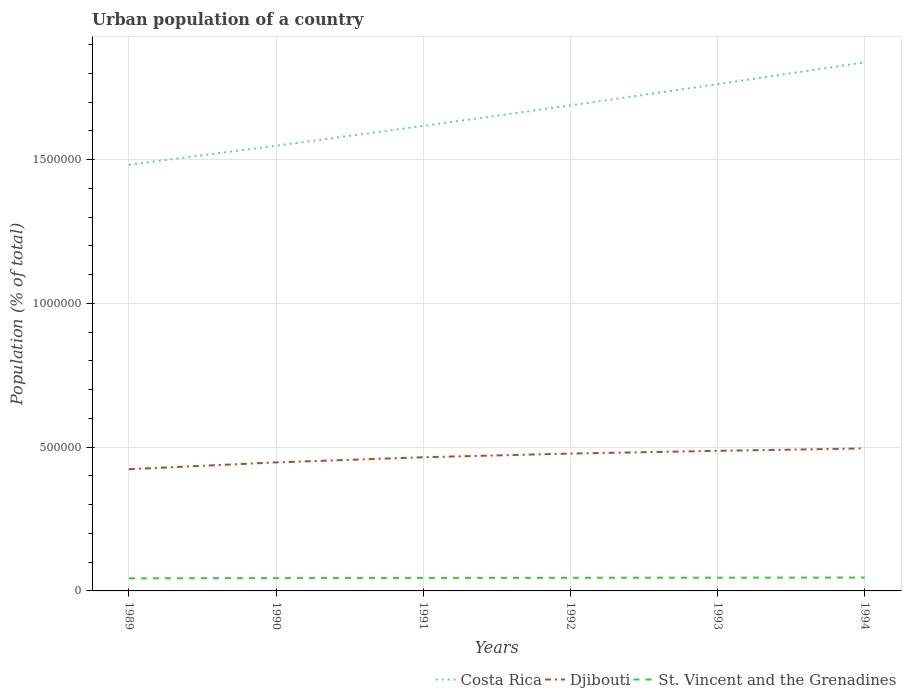How many different coloured lines are there?
Your response must be concise. 3. Does the line corresponding to Costa Rica intersect with the line corresponding to Djibouti?
Keep it short and to the point. No. Is the number of lines equal to the number of legend labels?
Offer a terse response. Yes. Across all years, what is the maximum urban population in Djibouti?
Your answer should be compact. 4.23e+05. What is the total urban population in Djibouti in the graph?
Provide a succinct answer. -8431. What is the difference between the highest and the second highest urban population in Djibouti?
Your response must be concise. 7.22e+04. How many lines are there?
Your answer should be very brief. 3. How many years are there in the graph?
Your answer should be very brief. 6. What is the difference between two consecutive major ticks on the Y-axis?
Offer a very short reply. 5.00e+05. Does the graph contain grids?
Your response must be concise. Yes. How many legend labels are there?
Your response must be concise. 3. What is the title of the graph?
Provide a short and direct response. Urban population of a country. What is the label or title of the Y-axis?
Your answer should be compact. Population (% of total). What is the Population (% of total) in Costa Rica in 1989?
Your answer should be very brief. 1.48e+06. What is the Population (% of total) of Djibouti in 1989?
Provide a succinct answer. 4.23e+05. What is the Population (% of total) of St. Vincent and the Grenadines in 1989?
Offer a terse response. 4.37e+04. What is the Population (% of total) in Costa Rica in 1990?
Make the answer very short. 1.55e+06. What is the Population (% of total) in Djibouti in 1990?
Your answer should be very brief. 4.47e+05. What is the Population (% of total) in St. Vincent and the Grenadines in 1990?
Provide a short and direct response. 4.45e+04. What is the Population (% of total) of Costa Rica in 1991?
Offer a very short reply. 1.62e+06. What is the Population (% of total) of Djibouti in 1991?
Offer a terse response. 4.65e+05. What is the Population (% of total) in St. Vincent and the Grenadines in 1991?
Ensure brevity in your answer.  4.52e+04. What is the Population (% of total) of Costa Rica in 1992?
Provide a short and direct response. 1.69e+06. What is the Population (% of total) in Djibouti in 1992?
Your answer should be compact. 4.78e+05. What is the Population (% of total) in St. Vincent and the Grenadines in 1992?
Offer a terse response. 4.57e+04. What is the Population (% of total) of Costa Rica in 1993?
Keep it short and to the point. 1.76e+06. What is the Population (% of total) in Djibouti in 1993?
Ensure brevity in your answer.  4.87e+05. What is the Population (% of total) of St. Vincent and the Grenadines in 1993?
Ensure brevity in your answer.  4.61e+04. What is the Population (% of total) of Costa Rica in 1994?
Keep it short and to the point. 1.84e+06. What is the Population (% of total) in Djibouti in 1994?
Your answer should be compact. 4.96e+05. What is the Population (% of total) of St. Vincent and the Grenadines in 1994?
Offer a terse response. 4.65e+04. Across all years, what is the maximum Population (% of total) of Costa Rica?
Provide a succinct answer. 1.84e+06. Across all years, what is the maximum Population (% of total) in Djibouti?
Your answer should be compact. 4.96e+05. Across all years, what is the maximum Population (% of total) of St. Vincent and the Grenadines?
Make the answer very short. 4.65e+04. Across all years, what is the minimum Population (% of total) of Costa Rica?
Your response must be concise. 1.48e+06. Across all years, what is the minimum Population (% of total) of Djibouti?
Offer a very short reply. 4.23e+05. Across all years, what is the minimum Population (% of total) in St. Vincent and the Grenadines?
Provide a succinct answer. 4.37e+04. What is the total Population (% of total) in Costa Rica in the graph?
Ensure brevity in your answer.  9.94e+06. What is the total Population (% of total) of Djibouti in the graph?
Provide a succinct answer. 2.80e+06. What is the total Population (% of total) of St. Vincent and the Grenadines in the graph?
Ensure brevity in your answer.  2.72e+05. What is the difference between the Population (% of total) in Costa Rica in 1989 and that in 1990?
Offer a terse response. -6.61e+04. What is the difference between the Population (% of total) in Djibouti in 1989 and that in 1990?
Your response must be concise. -2.36e+04. What is the difference between the Population (% of total) in St. Vincent and the Grenadines in 1989 and that in 1990?
Your response must be concise. -783. What is the difference between the Population (% of total) in Costa Rica in 1989 and that in 1991?
Offer a very short reply. -1.35e+05. What is the difference between the Population (% of total) in Djibouti in 1989 and that in 1991?
Provide a succinct answer. -4.15e+04. What is the difference between the Population (% of total) in St. Vincent and the Grenadines in 1989 and that in 1991?
Make the answer very short. -1491. What is the difference between the Population (% of total) of Costa Rica in 1989 and that in 1992?
Provide a succinct answer. -2.06e+05. What is the difference between the Population (% of total) of Djibouti in 1989 and that in 1992?
Ensure brevity in your answer.  -5.43e+04. What is the difference between the Population (% of total) of St. Vincent and the Grenadines in 1989 and that in 1992?
Keep it short and to the point. -1956. What is the difference between the Population (% of total) in Costa Rica in 1989 and that in 1993?
Provide a short and direct response. -2.80e+05. What is the difference between the Population (% of total) in Djibouti in 1989 and that in 1993?
Provide a short and direct response. -6.38e+04. What is the difference between the Population (% of total) in St. Vincent and the Grenadines in 1989 and that in 1993?
Your response must be concise. -2382. What is the difference between the Population (% of total) of Costa Rica in 1989 and that in 1994?
Keep it short and to the point. -3.56e+05. What is the difference between the Population (% of total) of Djibouti in 1989 and that in 1994?
Give a very brief answer. -7.22e+04. What is the difference between the Population (% of total) in St. Vincent and the Grenadines in 1989 and that in 1994?
Give a very brief answer. -2783. What is the difference between the Population (% of total) in Costa Rica in 1990 and that in 1991?
Provide a succinct answer. -6.89e+04. What is the difference between the Population (% of total) of Djibouti in 1990 and that in 1991?
Provide a short and direct response. -1.79e+04. What is the difference between the Population (% of total) in St. Vincent and the Grenadines in 1990 and that in 1991?
Your answer should be very brief. -708. What is the difference between the Population (% of total) of Costa Rica in 1990 and that in 1992?
Offer a very short reply. -1.40e+05. What is the difference between the Population (% of total) of Djibouti in 1990 and that in 1992?
Make the answer very short. -3.07e+04. What is the difference between the Population (% of total) of St. Vincent and the Grenadines in 1990 and that in 1992?
Keep it short and to the point. -1173. What is the difference between the Population (% of total) of Costa Rica in 1990 and that in 1993?
Your answer should be very brief. -2.14e+05. What is the difference between the Population (% of total) in Djibouti in 1990 and that in 1993?
Your response must be concise. -4.02e+04. What is the difference between the Population (% of total) in St. Vincent and the Grenadines in 1990 and that in 1993?
Your response must be concise. -1599. What is the difference between the Population (% of total) of Costa Rica in 1990 and that in 1994?
Give a very brief answer. -2.90e+05. What is the difference between the Population (% of total) of Djibouti in 1990 and that in 1994?
Make the answer very short. -4.87e+04. What is the difference between the Population (% of total) of St. Vincent and the Grenadines in 1990 and that in 1994?
Offer a very short reply. -2000. What is the difference between the Population (% of total) in Costa Rica in 1991 and that in 1992?
Your answer should be compact. -7.14e+04. What is the difference between the Population (% of total) of Djibouti in 1991 and that in 1992?
Give a very brief answer. -1.28e+04. What is the difference between the Population (% of total) of St. Vincent and the Grenadines in 1991 and that in 1992?
Make the answer very short. -465. What is the difference between the Population (% of total) of Costa Rica in 1991 and that in 1993?
Your response must be concise. -1.45e+05. What is the difference between the Population (% of total) in Djibouti in 1991 and that in 1993?
Your answer should be very brief. -2.23e+04. What is the difference between the Population (% of total) in St. Vincent and the Grenadines in 1991 and that in 1993?
Keep it short and to the point. -891. What is the difference between the Population (% of total) in Costa Rica in 1991 and that in 1994?
Make the answer very short. -2.21e+05. What is the difference between the Population (% of total) of Djibouti in 1991 and that in 1994?
Offer a terse response. -3.07e+04. What is the difference between the Population (% of total) of St. Vincent and the Grenadines in 1991 and that in 1994?
Provide a short and direct response. -1292. What is the difference between the Population (% of total) in Costa Rica in 1992 and that in 1993?
Keep it short and to the point. -7.37e+04. What is the difference between the Population (% of total) of Djibouti in 1992 and that in 1993?
Ensure brevity in your answer.  -9550. What is the difference between the Population (% of total) of St. Vincent and the Grenadines in 1992 and that in 1993?
Offer a terse response. -426. What is the difference between the Population (% of total) in Costa Rica in 1992 and that in 1994?
Keep it short and to the point. -1.50e+05. What is the difference between the Population (% of total) in Djibouti in 1992 and that in 1994?
Make the answer very short. -1.80e+04. What is the difference between the Population (% of total) in St. Vincent and the Grenadines in 1992 and that in 1994?
Offer a very short reply. -827. What is the difference between the Population (% of total) in Costa Rica in 1993 and that in 1994?
Provide a succinct answer. -7.58e+04. What is the difference between the Population (% of total) of Djibouti in 1993 and that in 1994?
Offer a very short reply. -8431. What is the difference between the Population (% of total) of St. Vincent and the Grenadines in 1993 and that in 1994?
Your response must be concise. -401. What is the difference between the Population (% of total) of Costa Rica in 1989 and the Population (% of total) of Djibouti in 1990?
Provide a succinct answer. 1.04e+06. What is the difference between the Population (% of total) in Costa Rica in 1989 and the Population (% of total) in St. Vincent and the Grenadines in 1990?
Offer a very short reply. 1.44e+06. What is the difference between the Population (% of total) in Djibouti in 1989 and the Population (% of total) in St. Vincent and the Grenadines in 1990?
Make the answer very short. 3.79e+05. What is the difference between the Population (% of total) in Costa Rica in 1989 and the Population (% of total) in Djibouti in 1991?
Provide a short and direct response. 1.02e+06. What is the difference between the Population (% of total) in Costa Rica in 1989 and the Population (% of total) in St. Vincent and the Grenadines in 1991?
Offer a very short reply. 1.44e+06. What is the difference between the Population (% of total) of Djibouti in 1989 and the Population (% of total) of St. Vincent and the Grenadines in 1991?
Provide a short and direct response. 3.78e+05. What is the difference between the Population (% of total) in Costa Rica in 1989 and the Population (% of total) in Djibouti in 1992?
Offer a very short reply. 1.00e+06. What is the difference between the Population (% of total) in Costa Rica in 1989 and the Population (% of total) in St. Vincent and the Grenadines in 1992?
Make the answer very short. 1.44e+06. What is the difference between the Population (% of total) of Djibouti in 1989 and the Population (% of total) of St. Vincent and the Grenadines in 1992?
Your answer should be very brief. 3.78e+05. What is the difference between the Population (% of total) in Costa Rica in 1989 and the Population (% of total) in Djibouti in 1993?
Ensure brevity in your answer.  9.95e+05. What is the difference between the Population (% of total) in Costa Rica in 1989 and the Population (% of total) in St. Vincent and the Grenadines in 1993?
Make the answer very short. 1.44e+06. What is the difference between the Population (% of total) of Djibouti in 1989 and the Population (% of total) of St. Vincent and the Grenadines in 1993?
Your answer should be very brief. 3.77e+05. What is the difference between the Population (% of total) in Costa Rica in 1989 and the Population (% of total) in Djibouti in 1994?
Provide a short and direct response. 9.86e+05. What is the difference between the Population (% of total) of Costa Rica in 1989 and the Population (% of total) of St. Vincent and the Grenadines in 1994?
Keep it short and to the point. 1.44e+06. What is the difference between the Population (% of total) of Djibouti in 1989 and the Population (% of total) of St. Vincent and the Grenadines in 1994?
Provide a short and direct response. 3.77e+05. What is the difference between the Population (% of total) of Costa Rica in 1990 and the Population (% of total) of Djibouti in 1991?
Your answer should be compact. 1.08e+06. What is the difference between the Population (% of total) of Costa Rica in 1990 and the Population (% of total) of St. Vincent and the Grenadines in 1991?
Keep it short and to the point. 1.50e+06. What is the difference between the Population (% of total) of Djibouti in 1990 and the Population (% of total) of St. Vincent and the Grenadines in 1991?
Your answer should be compact. 4.02e+05. What is the difference between the Population (% of total) in Costa Rica in 1990 and the Population (% of total) in Djibouti in 1992?
Offer a very short reply. 1.07e+06. What is the difference between the Population (% of total) in Costa Rica in 1990 and the Population (% of total) in St. Vincent and the Grenadines in 1992?
Keep it short and to the point. 1.50e+06. What is the difference between the Population (% of total) of Djibouti in 1990 and the Population (% of total) of St. Vincent and the Grenadines in 1992?
Ensure brevity in your answer.  4.01e+05. What is the difference between the Population (% of total) in Costa Rica in 1990 and the Population (% of total) in Djibouti in 1993?
Provide a succinct answer. 1.06e+06. What is the difference between the Population (% of total) of Costa Rica in 1990 and the Population (% of total) of St. Vincent and the Grenadines in 1993?
Provide a succinct answer. 1.50e+06. What is the difference between the Population (% of total) in Djibouti in 1990 and the Population (% of total) in St. Vincent and the Grenadines in 1993?
Your response must be concise. 4.01e+05. What is the difference between the Population (% of total) of Costa Rica in 1990 and the Population (% of total) of Djibouti in 1994?
Your answer should be very brief. 1.05e+06. What is the difference between the Population (% of total) in Costa Rica in 1990 and the Population (% of total) in St. Vincent and the Grenadines in 1994?
Ensure brevity in your answer.  1.50e+06. What is the difference between the Population (% of total) in Djibouti in 1990 and the Population (% of total) in St. Vincent and the Grenadines in 1994?
Keep it short and to the point. 4.00e+05. What is the difference between the Population (% of total) of Costa Rica in 1991 and the Population (% of total) of Djibouti in 1992?
Provide a succinct answer. 1.14e+06. What is the difference between the Population (% of total) in Costa Rica in 1991 and the Population (% of total) in St. Vincent and the Grenadines in 1992?
Your answer should be very brief. 1.57e+06. What is the difference between the Population (% of total) in Djibouti in 1991 and the Population (% of total) in St. Vincent and the Grenadines in 1992?
Your answer should be very brief. 4.19e+05. What is the difference between the Population (% of total) in Costa Rica in 1991 and the Population (% of total) in Djibouti in 1993?
Your response must be concise. 1.13e+06. What is the difference between the Population (% of total) in Costa Rica in 1991 and the Population (% of total) in St. Vincent and the Grenadines in 1993?
Your answer should be compact. 1.57e+06. What is the difference between the Population (% of total) of Djibouti in 1991 and the Population (% of total) of St. Vincent and the Grenadines in 1993?
Make the answer very short. 4.19e+05. What is the difference between the Population (% of total) in Costa Rica in 1991 and the Population (% of total) in Djibouti in 1994?
Provide a succinct answer. 1.12e+06. What is the difference between the Population (% of total) of Costa Rica in 1991 and the Population (% of total) of St. Vincent and the Grenadines in 1994?
Give a very brief answer. 1.57e+06. What is the difference between the Population (% of total) in Djibouti in 1991 and the Population (% of total) in St. Vincent and the Grenadines in 1994?
Ensure brevity in your answer.  4.18e+05. What is the difference between the Population (% of total) in Costa Rica in 1992 and the Population (% of total) in Djibouti in 1993?
Provide a succinct answer. 1.20e+06. What is the difference between the Population (% of total) of Costa Rica in 1992 and the Population (% of total) of St. Vincent and the Grenadines in 1993?
Ensure brevity in your answer.  1.64e+06. What is the difference between the Population (% of total) in Djibouti in 1992 and the Population (% of total) in St. Vincent and the Grenadines in 1993?
Offer a very short reply. 4.31e+05. What is the difference between the Population (% of total) in Costa Rica in 1992 and the Population (% of total) in Djibouti in 1994?
Your answer should be very brief. 1.19e+06. What is the difference between the Population (% of total) in Costa Rica in 1992 and the Population (% of total) in St. Vincent and the Grenadines in 1994?
Give a very brief answer. 1.64e+06. What is the difference between the Population (% of total) in Djibouti in 1992 and the Population (% of total) in St. Vincent and the Grenadines in 1994?
Ensure brevity in your answer.  4.31e+05. What is the difference between the Population (% of total) in Costa Rica in 1993 and the Population (% of total) in Djibouti in 1994?
Your answer should be compact. 1.27e+06. What is the difference between the Population (% of total) of Costa Rica in 1993 and the Population (% of total) of St. Vincent and the Grenadines in 1994?
Offer a terse response. 1.72e+06. What is the difference between the Population (% of total) of Djibouti in 1993 and the Population (% of total) of St. Vincent and the Grenadines in 1994?
Ensure brevity in your answer.  4.41e+05. What is the average Population (% of total) in Costa Rica per year?
Provide a succinct answer. 1.66e+06. What is the average Population (% of total) in Djibouti per year?
Your answer should be very brief. 4.66e+05. What is the average Population (% of total) of St. Vincent and the Grenadines per year?
Your response must be concise. 4.53e+04. In the year 1989, what is the difference between the Population (% of total) of Costa Rica and Population (% of total) of Djibouti?
Ensure brevity in your answer.  1.06e+06. In the year 1989, what is the difference between the Population (% of total) of Costa Rica and Population (% of total) of St. Vincent and the Grenadines?
Provide a succinct answer. 1.44e+06. In the year 1989, what is the difference between the Population (% of total) of Djibouti and Population (% of total) of St. Vincent and the Grenadines?
Your response must be concise. 3.80e+05. In the year 1990, what is the difference between the Population (% of total) of Costa Rica and Population (% of total) of Djibouti?
Your answer should be compact. 1.10e+06. In the year 1990, what is the difference between the Population (% of total) in Costa Rica and Population (% of total) in St. Vincent and the Grenadines?
Your response must be concise. 1.50e+06. In the year 1990, what is the difference between the Population (% of total) in Djibouti and Population (% of total) in St. Vincent and the Grenadines?
Offer a terse response. 4.02e+05. In the year 1991, what is the difference between the Population (% of total) in Costa Rica and Population (% of total) in Djibouti?
Make the answer very short. 1.15e+06. In the year 1991, what is the difference between the Population (% of total) in Costa Rica and Population (% of total) in St. Vincent and the Grenadines?
Your answer should be very brief. 1.57e+06. In the year 1991, what is the difference between the Population (% of total) in Djibouti and Population (% of total) in St. Vincent and the Grenadines?
Give a very brief answer. 4.20e+05. In the year 1992, what is the difference between the Population (% of total) in Costa Rica and Population (% of total) in Djibouti?
Your answer should be very brief. 1.21e+06. In the year 1992, what is the difference between the Population (% of total) in Costa Rica and Population (% of total) in St. Vincent and the Grenadines?
Provide a succinct answer. 1.64e+06. In the year 1992, what is the difference between the Population (% of total) of Djibouti and Population (% of total) of St. Vincent and the Grenadines?
Your answer should be very brief. 4.32e+05. In the year 1993, what is the difference between the Population (% of total) in Costa Rica and Population (% of total) in Djibouti?
Your response must be concise. 1.27e+06. In the year 1993, what is the difference between the Population (% of total) of Costa Rica and Population (% of total) of St. Vincent and the Grenadines?
Provide a succinct answer. 1.72e+06. In the year 1993, what is the difference between the Population (% of total) in Djibouti and Population (% of total) in St. Vincent and the Grenadines?
Offer a terse response. 4.41e+05. In the year 1994, what is the difference between the Population (% of total) in Costa Rica and Population (% of total) in Djibouti?
Make the answer very short. 1.34e+06. In the year 1994, what is the difference between the Population (% of total) of Costa Rica and Population (% of total) of St. Vincent and the Grenadines?
Offer a terse response. 1.79e+06. In the year 1994, what is the difference between the Population (% of total) of Djibouti and Population (% of total) of St. Vincent and the Grenadines?
Provide a short and direct response. 4.49e+05. What is the ratio of the Population (% of total) in Costa Rica in 1989 to that in 1990?
Provide a short and direct response. 0.96. What is the ratio of the Population (% of total) of Djibouti in 1989 to that in 1990?
Provide a succinct answer. 0.95. What is the ratio of the Population (% of total) of St. Vincent and the Grenadines in 1989 to that in 1990?
Give a very brief answer. 0.98. What is the ratio of the Population (% of total) of Costa Rica in 1989 to that in 1991?
Your answer should be compact. 0.92. What is the ratio of the Population (% of total) in Djibouti in 1989 to that in 1991?
Provide a short and direct response. 0.91. What is the ratio of the Population (% of total) of Costa Rica in 1989 to that in 1992?
Keep it short and to the point. 0.88. What is the ratio of the Population (% of total) of Djibouti in 1989 to that in 1992?
Offer a very short reply. 0.89. What is the ratio of the Population (% of total) in St. Vincent and the Grenadines in 1989 to that in 1992?
Your response must be concise. 0.96. What is the ratio of the Population (% of total) of Costa Rica in 1989 to that in 1993?
Offer a very short reply. 0.84. What is the ratio of the Population (% of total) in Djibouti in 1989 to that in 1993?
Make the answer very short. 0.87. What is the ratio of the Population (% of total) in St. Vincent and the Grenadines in 1989 to that in 1993?
Your answer should be compact. 0.95. What is the ratio of the Population (% of total) in Costa Rica in 1989 to that in 1994?
Provide a short and direct response. 0.81. What is the ratio of the Population (% of total) in Djibouti in 1989 to that in 1994?
Provide a short and direct response. 0.85. What is the ratio of the Population (% of total) of St. Vincent and the Grenadines in 1989 to that in 1994?
Your answer should be compact. 0.94. What is the ratio of the Population (% of total) in Costa Rica in 1990 to that in 1991?
Offer a very short reply. 0.96. What is the ratio of the Population (% of total) of Djibouti in 1990 to that in 1991?
Your answer should be compact. 0.96. What is the ratio of the Population (% of total) in St. Vincent and the Grenadines in 1990 to that in 1991?
Ensure brevity in your answer.  0.98. What is the ratio of the Population (% of total) of Costa Rica in 1990 to that in 1992?
Offer a terse response. 0.92. What is the ratio of the Population (% of total) of Djibouti in 1990 to that in 1992?
Provide a succinct answer. 0.94. What is the ratio of the Population (% of total) of St. Vincent and the Grenadines in 1990 to that in 1992?
Provide a succinct answer. 0.97. What is the ratio of the Population (% of total) of Costa Rica in 1990 to that in 1993?
Your answer should be compact. 0.88. What is the ratio of the Population (% of total) of Djibouti in 1990 to that in 1993?
Keep it short and to the point. 0.92. What is the ratio of the Population (% of total) of St. Vincent and the Grenadines in 1990 to that in 1993?
Give a very brief answer. 0.97. What is the ratio of the Population (% of total) of Costa Rica in 1990 to that in 1994?
Ensure brevity in your answer.  0.84. What is the ratio of the Population (% of total) of Djibouti in 1990 to that in 1994?
Your response must be concise. 0.9. What is the ratio of the Population (% of total) in St. Vincent and the Grenadines in 1990 to that in 1994?
Offer a very short reply. 0.96. What is the ratio of the Population (% of total) in Costa Rica in 1991 to that in 1992?
Provide a short and direct response. 0.96. What is the ratio of the Population (% of total) of Djibouti in 1991 to that in 1992?
Your response must be concise. 0.97. What is the ratio of the Population (% of total) in Costa Rica in 1991 to that in 1993?
Provide a short and direct response. 0.92. What is the ratio of the Population (% of total) of Djibouti in 1991 to that in 1993?
Your response must be concise. 0.95. What is the ratio of the Population (% of total) in St. Vincent and the Grenadines in 1991 to that in 1993?
Your response must be concise. 0.98. What is the ratio of the Population (% of total) in Costa Rica in 1991 to that in 1994?
Your response must be concise. 0.88. What is the ratio of the Population (% of total) in Djibouti in 1991 to that in 1994?
Make the answer very short. 0.94. What is the ratio of the Population (% of total) in St. Vincent and the Grenadines in 1991 to that in 1994?
Give a very brief answer. 0.97. What is the ratio of the Population (% of total) in Costa Rica in 1992 to that in 1993?
Ensure brevity in your answer.  0.96. What is the ratio of the Population (% of total) of Djibouti in 1992 to that in 1993?
Keep it short and to the point. 0.98. What is the ratio of the Population (% of total) of St. Vincent and the Grenadines in 1992 to that in 1993?
Provide a succinct answer. 0.99. What is the ratio of the Population (% of total) in Costa Rica in 1992 to that in 1994?
Your answer should be very brief. 0.92. What is the ratio of the Population (% of total) of Djibouti in 1992 to that in 1994?
Your answer should be very brief. 0.96. What is the ratio of the Population (% of total) in St. Vincent and the Grenadines in 1992 to that in 1994?
Provide a short and direct response. 0.98. What is the ratio of the Population (% of total) of Costa Rica in 1993 to that in 1994?
Keep it short and to the point. 0.96. What is the difference between the highest and the second highest Population (% of total) in Costa Rica?
Provide a short and direct response. 7.58e+04. What is the difference between the highest and the second highest Population (% of total) in Djibouti?
Ensure brevity in your answer.  8431. What is the difference between the highest and the second highest Population (% of total) of St. Vincent and the Grenadines?
Your answer should be compact. 401. What is the difference between the highest and the lowest Population (% of total) of Costa Rica?
Give a very brief answer. 3.56e+05. What is the difference between the highest and the lowest Population (% of total) of Djibouti?
Offer a very short reply. 7.22e+04. What is the difference between the highest and the lowest Population (% of total) of St. Vincent and the Grenadines?
Provide a succinct answer. 2783. 